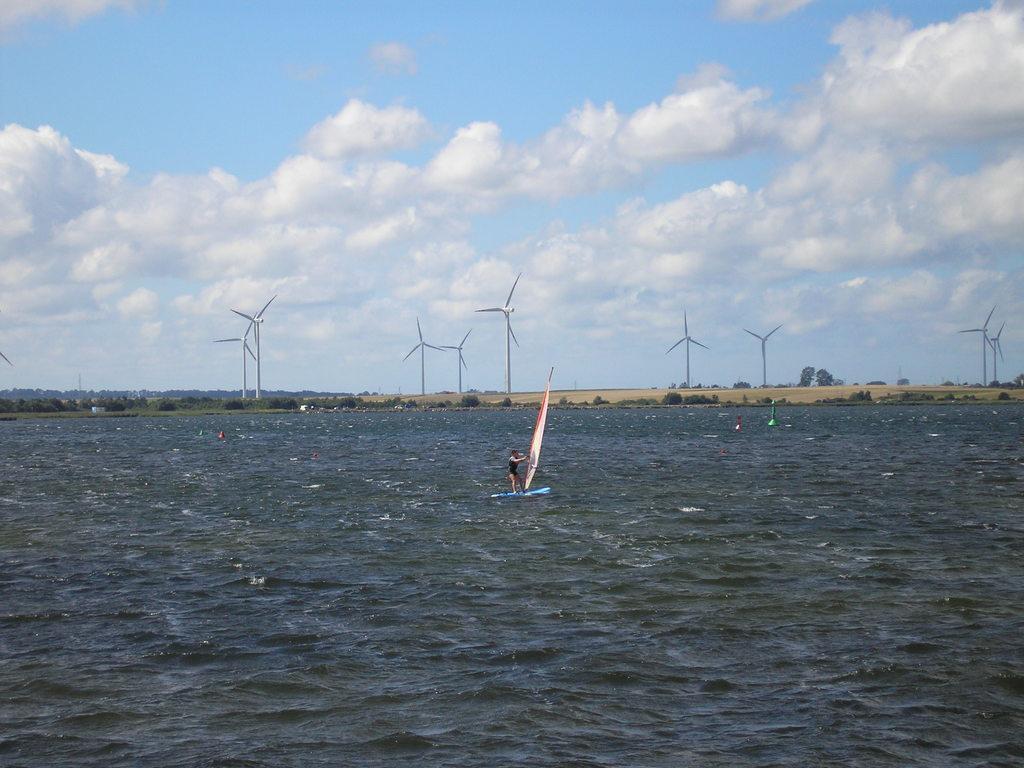Could you give a brief overview of what you see in this image? In this image, I can see a person doing windsurfing. This looks like a sea with the water flowing. These are the windmills. I can see trees and small bushes. These are the clouds in the sky. 